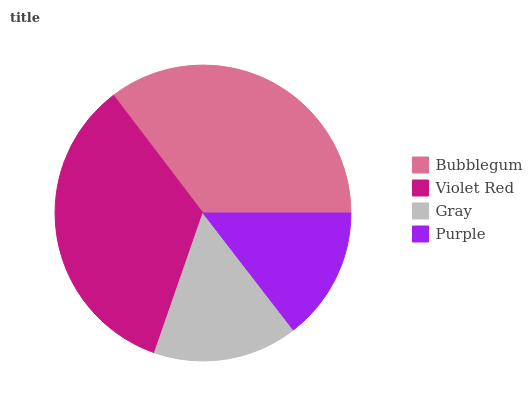Is Purple the minimum?
Answer yes or no. Yes. Is Bubblegum the maximum?
Answer yes or no. Yes. Is Violet Red the minimum?
Answer yes or no. No. Is Violet Red the maximum?
Answer yes or no. No. Is Bubblegum greater than Violet Red?
Answer yes or no. Yes. Is Violet Red less than Bubblegum?
Answer yes or no. Yes. Is Violet Red greater than Bubblegum?
Answer yes or no. No. Is Bubblegum less than Violet Red?
Answer yes or no. No. Is Violet Red the high median?
Answer yes or no. Yes. Is Gray the low median?
Answer yes or no. Yes. Is Purple the high median?
Answer yes or no. No. Is Violet Red the low median?
Answer yes or no. No. 